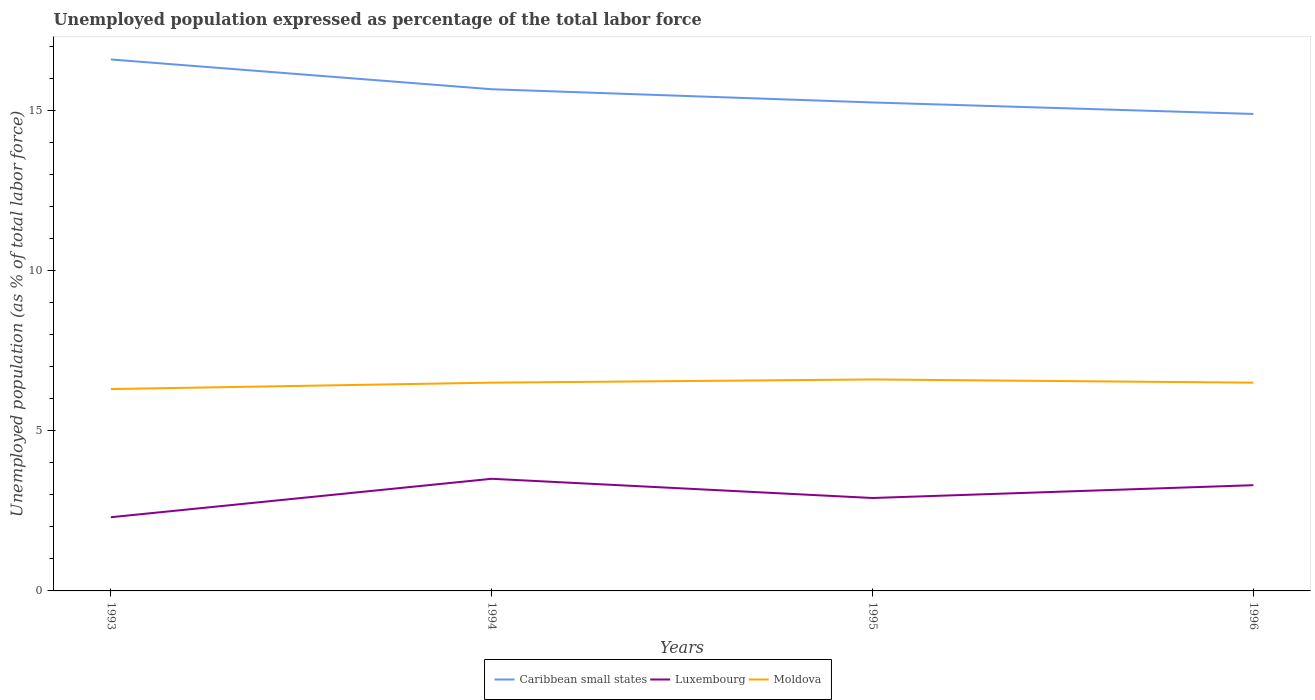How many different coloured lines are there?
Your answer should be very brief. 3. Does the line corresponding to Caribbean small states intersect with the line corresponding to Moldova?
Provide a succinct answer. No. Across all years, what is the maximum unemployment in in Caribbean small states?
Ensure brevity in your answer.  14.89. What is the total unemployment in in Moldova in the graph?
Make the answer very short. -0.2. What is the difference between the highest and the second highest unemployment in in Caribbean small states?
Your response must be concise. 1.7. Is the unemployment in in Caribbean small states strictly greater than the unemployment in in Moldova over the years?
Offer a very short reply. No. How many lines are there?
Your response must be concise. 3. What is the difference between two consecutive major ticks on the Y-axis?
Provide a short and direct response. 5. Does the graph contain grids?
Keep it short and to the point. No. Where does the legend appear in the graph?
Ensure brevity in your answer.  Bottom center. How many legend labels are there?
Make the answer very short. 3. How are the legend labels stacked?
Make the answer very short. Horizontal. What is the title of the graph?
Your response must be concise. Unemployed population expressed as percentage of the total labor force. Does "Montenegro" appear as one of the legend labels in the graph?
Your answer should be very brief. No. What is the label or title of the Y-axis?
Provide a succinct answer. Unemployed population (as % of total labor force). What is the Unemployed population (as % of total labor force) of Caribbean small states in 1993?
Give a very brief answer. 16.59. What is the Unemployed population (as % of total labor force) of Luxembourg in 1993?
Offer a very short reply. 2.3. What is the Unemployed population (as % of total labor force) in Moldova in 1993?
Keep it short and to the point. 6.3. What is the Unemployed population (as % of total labor force) in Caribbean small states in 1994?
Offer a terse response. 15.66. What is the Unemployed population (as % of total labor force) of Luxembourg in 1994?
Ensure brevity in your answer.  3.5. What is the Unemployed population (as % of total labor force) in Caribbean small states in 1995?
Make the answer very short. 15.25. What is the Unemployed population (as % of total labor force) of Luxembourg in 1995?
Give a very brief answer. 2.9. What is the Unemployed population (as % of total labor force) of Moldova in 1995?
Provide a succinct answer. 6.6. What is the Unemployed population (as % of total labor force) of Caribbean small states in 1996?
Provide a succinct answer. 14.89. What is the Unemployed population (as % of total labor force) of Luxembourg in 1996?
Your answer should be compact. 3.3. What is the Unemployed population (as % of total labor force) in Moldova in 1996?
Keep it short and to the point. 6.5. Across all years, what is the maximum Unemployed population (as % of total labor force) in Caribbean small states?
Make the answer very short. 16.59. Across all years, what is the maximum Unemployed population (as % of total labor force) in Moldova?
Keep it short and to the point. 6.6. Across all years, what is the minimum Unemployed population (as % of total labor force) in Caribbean small states?
Your answer should be very brief. 14.89. Across all years, what is the minimum Unemployed population (as % of total labor force) in Luxembourg?
Provide a succinct answer. 2.3. Across all years, what is the minimum Unemployed population (as % of total labor force) in Moldova?
Your answer should be compact. 6.3. What is the total Unemployed population (as % of total labor force) in Caribbean small states in the graph?
Ensure brevity in your answer.  62.38. What is the total Unemployed population (as % of total labor force) of Moldova in the graph?
Your answer should be very brief. 25.9. What is the difference between the Unemployed population (as % of total labor force) of Caribbean small states in 1993 and that in 1994?
Your answer should be compact. 0.93. What is the difference between the Unemployed population (as % of total labor force) in Moldova in 1993 and that in 1994?
Provide a succinct answer. -0.2. What is the difference between the Unemployed population (as % of total labor force) in Caribbean small states in 1993 and that in 1995?
Your response must be concise. 1.34. What is the difference between the Unemployed population (as % of total labor force) of Luxembourg in 1993 and that in 1995?
Offer a terse response. -0.6. What is the difference between the Unemployed population (as % of total labor force) of Caribbean small states in 1993 and that in 1996?
Provide a succinct answer. 1.7. What is the difference between the Unemployed population (as % of total labor force) in Caribbean small states in 1994 and that in 1995?
Keep it short and to the point. 0.41. What is the difference between the Unemployed population (as % of total labor force) in Luxembourg in 1994 and that in 1995?
Your answer should be compact. 0.6. What is the difference between the Unemployed population (as % of total labor force) in Caribbean small states in 1994 and that in 1996?
Provide a short and direct response. 0.77. What is the difference between the Unemployed population (as % of total labor force) of Caribbean small states in 1995 and that in 1996?
Ensure brevity in your answer.  0.36. What is the difference between the Unemployed population (as % of total labor force) in Luxembourg in 1995 and that in 1996?
Offer a terse response. -0.4. What is the difference between the Unemployed population (as % of total labor force) of Caribbean small states in 1993 and the Unemployed population (as % of total labor force) of Luxembourg in 1994?
Ensure brevity in your answer.  13.09. What is the difference between the Unemployed population (as % of total labor force) of Caribbean small states in 1993 and the Unemployed population (as % of total labor force) of Moldova in 1994?
Offer a very short reply. 10.09. What is the difference between the Unemployed population (as % of total labor force) of Caribbean small states in 1993 and the Unemployed population (as % of total labor force) of Luxembourg in 1995?
Provide a succinct answer. 13.69. What is the difference between the Unemployed population (as % of total labor force) in Caribbean small states in 1993 and the Unemployed population (as % of total labor force) in Moldova in 1995?
Ensure brevity in your answer.  9.99. What is the difference between the Unemployed population (as % of total labor force) of Caribbean small states in 1993 and the Unemployed population (as % of total labor force) of Luxembourg in 1996?
Offer a very short reply. 13.29. What is the difference between the Unemployed population (as % of total labor force) in Caribbean small states in 1993 and the Unemployed population (as % of total labor force) in Moldova in 1996?
Offer a very short reply. 10.09. What is the difference between the Unemployed population (as % of total labor force) in Caribbean small states in 1994 and the Unemployed population (as % of total labor force) in Luxembourg in 1995?
Your response must be concise. 12.76. What is the difference between the Unemployed population (as % of total labor force) of Caribbean small states in 1994 and the Unemployed population (as % of total labor force) of Moldova in 1995?
Offer a terse response. 9.06. What is the difference between the Unemployed population (as % of total labor force) in Caribbean small states in 1994 and the Unemployed population (as % of total labor force) in Luxembourg in 1996?
Your answer should be very brief. 12.36. What is the difference between the Unemployed population (as % of total labor force) in Caribbean small states in 1994 and the Unemployed population (as % of total labor force) in Moldova in 1996?
Give a very brief answer. 9.16. What is the difference between the Unemployed population (as % of total labor force) of Caribbean small states in 1995 and the Unemployed population (as % of total labor force) of Luxembourg in 1996?
Your answer should be compact. 11.95. What is the difference between the Unemployed population (as % of total labor force) in Caribbean small states in 1995 and the Unemployed population (as % of total labor force) in Moldova in 1996?
Offer a very short reply. 8.75. What is the average Unemployed population (as % of total labor force) in Caribbean small states per year?
Provide a succinct answer. 15.59. What is the average Unemployed population (as % of total labor force) in Luxembourg per year?
Your response must be concise. 3. What is the average Unemployed population (as % of total labor force) of Moldova per year?
Offer a terse response. 6.47. In the year 1993, what is the difference between the Unemployed population (as % of total labor force) in Caribbean small states and Unemployed population (as % of total labor force) in Luxembourg?
Your response must be concise. 14.29. In the year 1993, what is the difference between the Unemployed population (as % of total labor force) in Caribbean small states and Unemployed population (as % of total labor force) in Moldova?
Provide a short and direct response. 10.29. In the year 1993, what is the difference between the Unemployed population (as % of total labor force) of Luxembourg and Unemployed population (as % of total labor force) of Moldova?
Make the answer very short. -4. In the year 1994, what is the difference between the Unemployed population (as % of total labor force) in Caribbean small states and Unemployed population (as % of total labor force) in Luxembourg?
Your answer should be compact. 12.16. In the year 1994, what is the difference between the Unemployed population (as % of total labor force) of Caribbean small states and Unemployed population (as % of total labor force) of Moldova?
Give a very brief answer. 9.16. In the year 1994, what is the difference between the Unemployed population (as % of total labor force) in Luxembourg and Unemployed population (as % of total labor force) in Moldova?
Your answer should be very brief. -3. In the year 1995, what is the difference between the Unemployed population (as % of total labor force) of Caribbean small states and Unemployed population (as % of total labor force) of Luxembourg?
Keep it short and to the point. 12.35. In the year 1995, what is the difference between the Unemployed population (as % of total labor force) of Caribbean small states and Unemployed population (as % of total labor force) of Moldova?
Your answer should be very brief. 8.65. In the year 1995, what is the difference between the Unemployed population (as % of total labor force) of Luxembourg and Unemployed population (as % of total labor force) of Moldova?
Your response must be concise. -3.7. In the year 1996, what is the difference between the Unemployed population (as % of total labor force) in Caribbean small states and Unemployed population (as % of total labor force) in Luxembourg?
Provide a succinct answer. 11.59. In the year 1996, what is the difference between the Unemployed population (as % of total labor force) in Caribbean small states and Unemployed population (as % of total labor force) in Moldova?
Keep it short and to the point. 8.39. In the year 1996, what is the difference between the Unemployed population (as % of total labor force) in Luxembourg and Unemployed population (as % of total labor force) in Moldova?
Offer a very short reply. -3.2. What is the ratio of the Unemployed population (as % of total labor force) in Caribbean small states in 1993 to that in 1994?
Your answer should be very brief. 1.06. What is the ratio of the Unemployed population (as % of total labor force) in Luxembourg in 1993 to that in 1994?
Offer a terse response. 0.66. What is the ratio of the Unemployed population (as % of total labor force) in Moldova in 1993 to that in 1994?
Your answer should be compact. 0.97. What is the ratio of the Unemployed population (as % of total labor force) of Caribbean small states in 1993 to that in 1995?
Your answer should be compact. 1.09. What is the ratio of the Unemployed population (as % of total labor force) in Luxembourg in 1993 to that in 1995?
Give a very brief answer. 0.79. What is the ratio of the Unemployed population (as % of total labor force) of Moldova in 1993 to that in 1995?
Make the answer very short. 0.95. What is the ratio of the Unemployed population (as % of total labor force) in Caribbean small states in 1993 to that in 1996?
Your response must be concise. 1.11. What is the ratio of the Unemployed population (as % of total labor force) of Luxembourg in 1993 to that in 1996?
Offer a very short reply. 0.7. What is the ratio of the Unemployed population (as % of total labor force) in Moldova in 1993 to that in 1996?
Provide a short and direct response. 0.97. What is the ratio of the Unemployed population (as % of total labor force) of Caribbean small states in 1994 to that in 1995?
Your answer should be very brief. 1.03. What is the ratio of the Unemployed population (as % of total labor force) in Luxembourg in 1994 to that in 1995?
Provide a short and direct response. 1.21. What is the ratio of the Unemployed population (as % of total labor force) in Caribbean small states in 1994 to that in 1996?
Provide a succinct answer. 1.05. What is the ratio of the Unemployed population (as % of total labor force) in Luxembourg in 1994 to that in 1996?
Offer a very short reply. 1.06. What is the ratio of the Unemployed population (as % of total labor force) of Caribbean small states in 1995 to that in 1996?
Make the answer very short. 1.02. What is the ratio of the Unemployed population (as % of total labor force) of Luxembourg in 1995 to that in 1996?
Give a very brief answer. 0.88. What is the ratio of the Unemployed population (as % of total labor force) in Moldova in 1995 to that in 1996?
Your answer should be very brief. 1.02. What is the difference between the highest and the second highest Unemployed population (as % of total labor force) in Caribbean small states?
Your response must be concise. 0.93. What is the difference between the highest and the second highest Unemployed population (as % of total labor force) in Luxembourg?
Your response must be concise. 0.2. What is the difference between the highest and the second highest Unemployed population (as % of total labor force) in Moldova?
Provide a short and direct response. 0.1. What is the difference between the highest and the lowest Unemployed population (as % of total labor force) of Caribbean small states?
Your answer should be very brief. 1.7. What is the difference between the highest and the lowest Unemployed population (as % of total labor force) in Moldova?
Your answer should be compact. 0.3. 